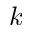Convert formula to latex. <formula><loc_0><loc_0><loc_500><loc_500>k</formula> 